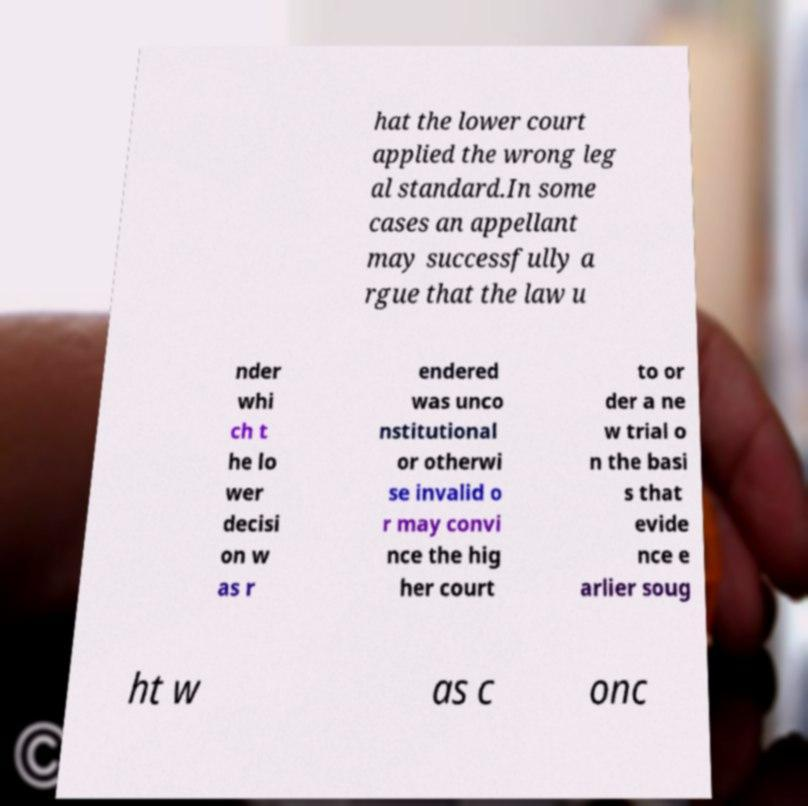Can you accurately transcribe the text from the provided image for me? hat the lower court applied the wrong leg al standard.In some cases an appellant may successfully a rgue that the law u nder whi ch t he lo wer decisi on w as r endered was unco nstitutional or otherwi se invalid o r may convi nce the hig her court to or der a ne w trial o n the basi s that evide nce e arlier soug ht w as c onc 